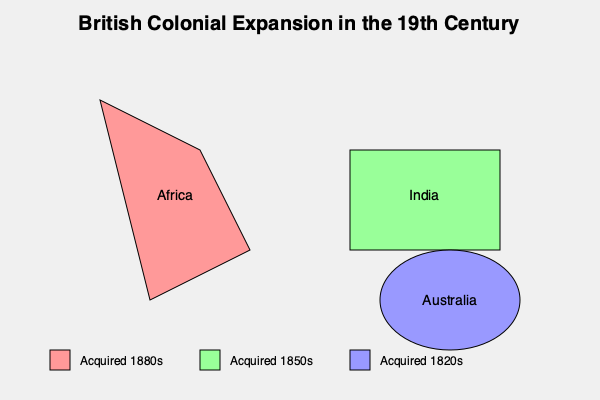Based on the map of British colonial expansion during the 19th century, which of the three major regions shown was acquired earliest by the British Empire? To answer this question, we need to analyze the information provided in the map:

1. The map shows three major regions of British colonial expansion: Africa, India, and Australia.

2. Each region is color-coded, and the legend at the bottom of the map provides information about when each color represents in terms of acquisition:
   - Red (pink) represents areas acquired in the 1880s
   - Green represents areas acquired in the 1850s
   - Blue represents areas acquired in the 1820s

3. Looking at the map:
   - Africa is colored red (pink), indicating it was acquired in the 1880s
   - India is colored green, indicating it was acquired in the 1850s
   - Australia is colored blue, indicating it was acquired in the 1820s

4. Among these three dates, the 1820s is the earliest.

5. Therefore, Australia, being colored blue and associated with the 1820s, was acquired earliest among the three major regions shown on the map.
Answer: Australia 